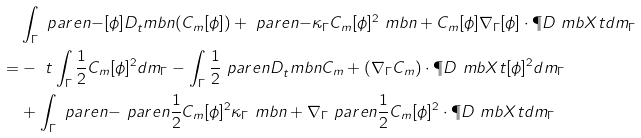Convert formula to latex. <formula><loc_0><loc_0><loc_500><loc_500>& \int _ { \Gamma } \ p a r e n { - [ \phi ] D _ { t } ^ { \ } m b { n } ( C _ { m } [ \phi ] ) + \ p a r e n { - \kappa _ { \Gamma } C _ { m } [ \phi ] ^ { 2 } \ m b { n } + C _ { m } [ \phi ] \nabla _ { \Gamma } [ \phi ] } \cdot \P D { \ m b { X } } { t } } d m _ { \Gamma } \\ = & - \ { t } \int _ { \Gamma } \frac { 1 } { 2 } C _ { m } [ \phi ] ^ { 2 } d m _ { \Gamma } - \int _ { \Gamma } \frac { 1 } { 2 } \ p a r e n { D _ { t } ^ { \ } m b { n } C _ { m } + ( \nabla _ { \Gamma } C _ { m } ) \cdot \P D { \ m b { X } } { t } } [ \phi ] ^ { 2 } d m _ { \Gamma } \\ & + \int _ { \Gamma } \ p a r e n { - \ p a r e n { \frac { 1 } { 2 } C _ { m } [ \phi ] ^ { 2 } } \kappa _ { \Gamma } \ m b { n } + \nabla _ { \Gamma } \ p a r e n { \frac { 1 } { 2 } C _ { m } [ \phi ] ^ { 2 } } } \cdot \P D { \ m b { X } } { t } d m _ { \Gamma } \\</formula> 